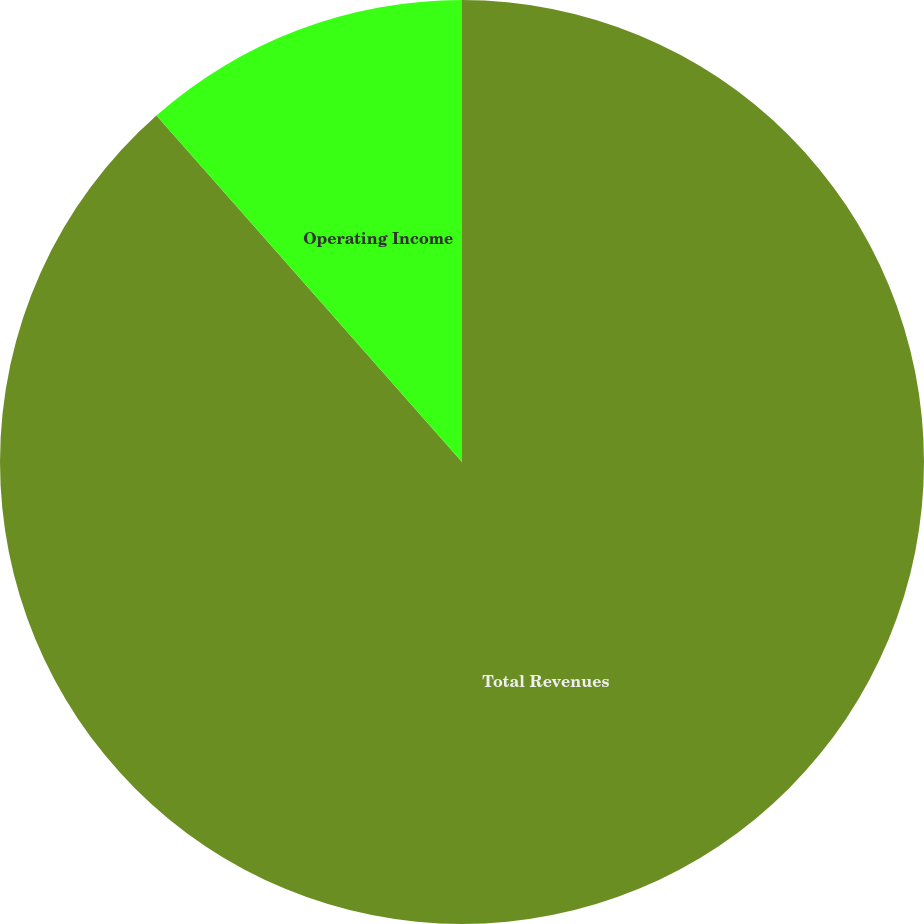<chart> <loc_0><loc_0><loc_500><loc_500><pie_chart><fcel>Total Revenues<fcel>Operating Income<nl><fcel>88.5%<fcel>11.5%<nl></chart> 